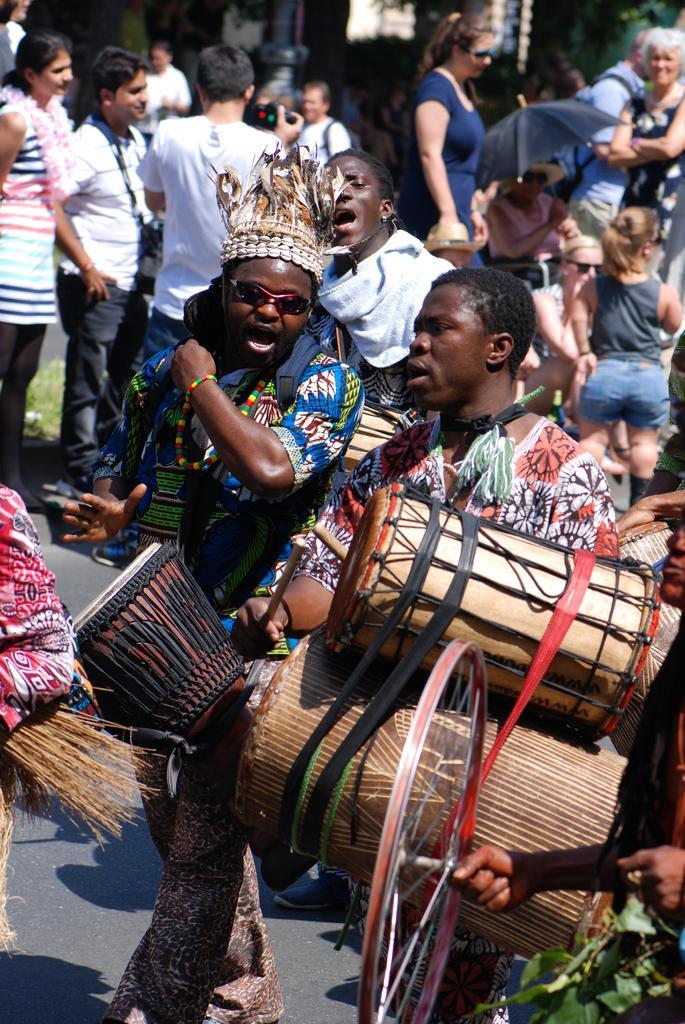Could you give a brief overview of what you see in this image? As we can see in the image there are few people standing here and there and the man who is standing here is holding musical drums. 